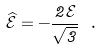<formula> <loc_0><loc_0><loc_500><loc_500>\widehat { \mathcal { E } } = - \frac { 2 \mathcal { E } } { \sqrt { 3 } } \ .</formula> 